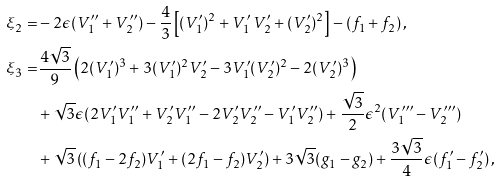Convert formula to latex. <formula><loc_0><loc_0><loc_500><loc_500>\xi _ { 2 } = & - 2 \epsilon ( V _ { 1 } ^ { \prime \prime } + V _ { 2 } ^ { \prime \prime } ) - \frac { 4 } { 3 } \left [ ( V _ { 1 } ^ { \prime } ) ^ { 2 } + V _ { 1 } ^ { \prime } \, V _ { 2 } ^ { \prime } + ( V _ { 2 } ^ { \prime } ) ^ { 2 } \right ] - ( f _ { 1 } + f _ { 2 } ) \, , \\ \xi _ { 3 } = & \frac { 4 \sqrt { 3 } } { 9 } \left ( 2 ( V _ { 1 } ^ { \prime } ) ^ { 3 } + 3 ( V _ { 1 } ^ { \prime } ) ^ { 2 } V _ { 2 } ^ { \prime } - 3 V _ { 1 } ^ { \prime } ( V _ { 2 } ^ { \prime } ) ^ { 2 } - 2 ( V _ { 2 } ^ { \prime } ) ^ { 3 } \right ) \\ & + \sqrt { 3 } \epsilon ( 2 V _ { 1 } ^ { \prime } V _ { 1 } ^ { \prime \prime } + V _ { 2 } ^ { \prime } V _ { 1 } ^ { \prime \prime } - 2 V _ { 2 } ^ { \prime } V _ { 2 } ^ { \prime \prime } - V _ { 1 } ^ { \prime } V _ { 2 } ^ { \prime \prime } ) + \frac { \sqrt { 3 } } { 2 } \epsilon ^ { 2 } ( V _ { 1 } ^ { \prime \prime \prime } - V _ { 2 } ^ { \prime \prime \prime } ) \\ & + \sqrt { 3 } \left ( ( f _ { 1 } - 2 f _ { 2 } ) V _ { 1 } ^ { \prime } + ( 2 f _ { 1 } - f _ { 2 } ) V _ { 2 } ^ { \prime } \right ) + 3 \sqrt { 3 } ( g _ { 1 } - g _ { 2 } ) + \frac { 3 \sqrt { 3 } } 4 \epsilon ( f _ { 1 } ^ { \prime } - f _ { 2 } ^ { \prime } ) \, ,</formula> 